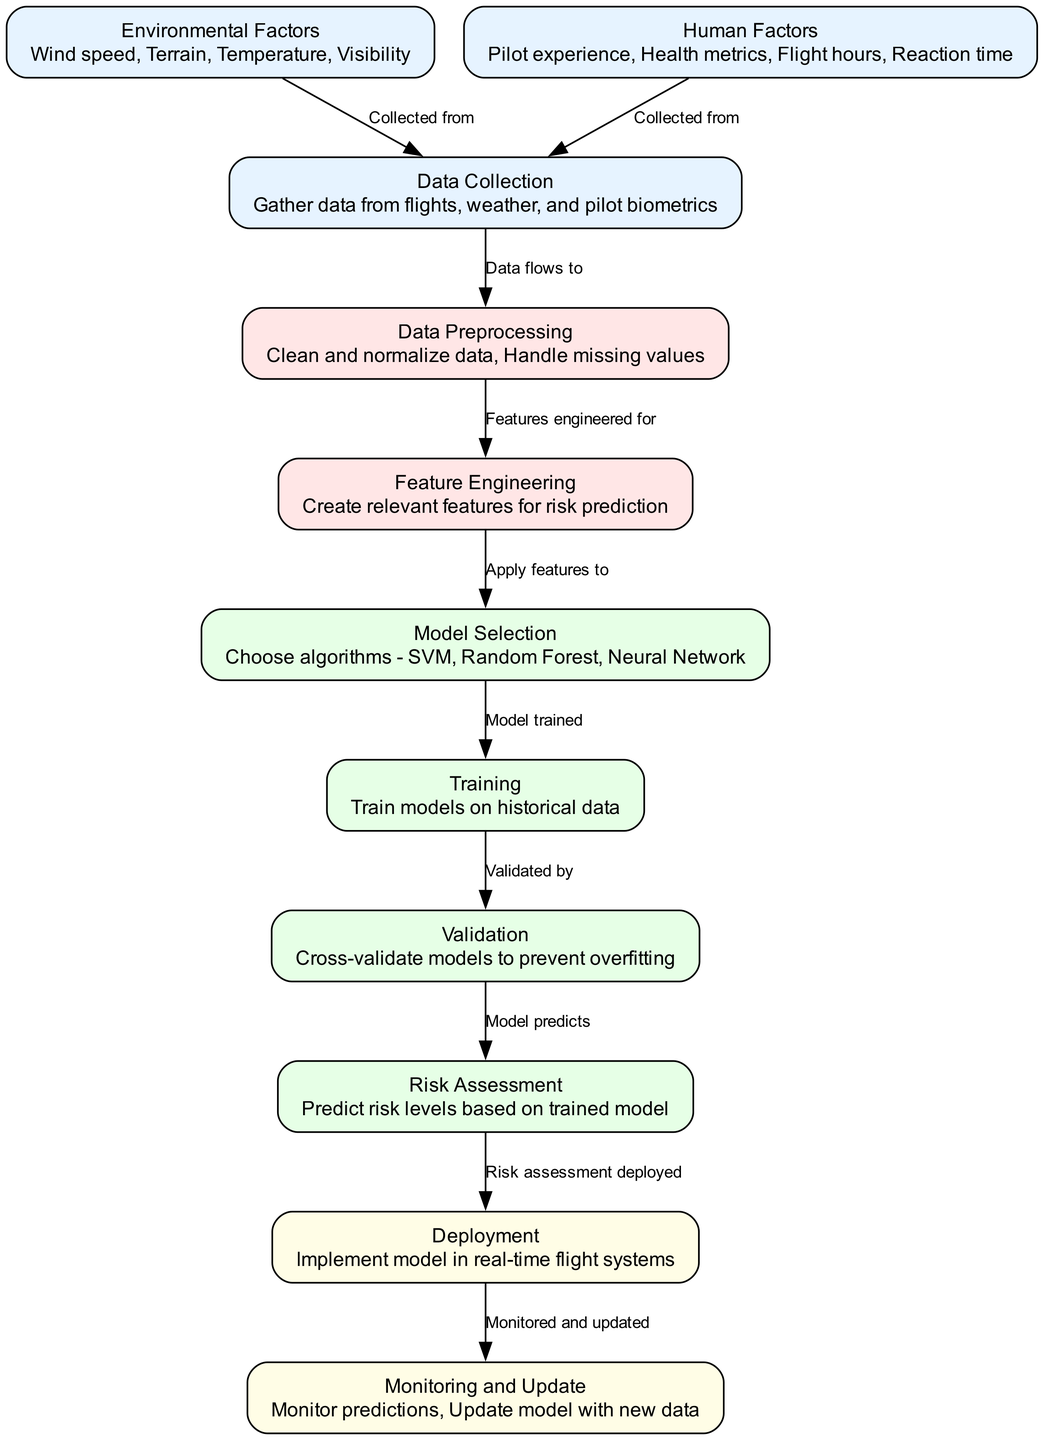What is the first step in the process? The diagram starts with the "Data Collection" node, which is the initial step where data is gathered from flights, weather, and pilot biometrics.
Answer: Data Collection How many types of factors are considered in the assessment? The diagram shows two distinct types of factors: "Environmental Factors" and "Human Factors," detailing both in separate nodes.
Answer: Two Which node provides features for model selection? The "Feature Engineering" node processes data collected in the "Data Preprocessing" stage and creates relevant features that are applied in "Model Selection."
Answer: Feature Engineering What type of algorithm can be selected in the "Model Selection" node? The "Model Selection" node allows for various algorithm choices, including SVM, Random Forest, and Neural Network.
Answer: SVM, Random Forest, Neural Network What is the final step after monitoring and updating the model? The "Monitoring and Update" node is the last step in the diagram, indicating that the model is continually watched and updated with new data.
Answer: Monitoring and Update How does data flow from environmental factors to the assessment process? The "Environmental Factors" node directs its data to the "Data Collection" node, which gathers all relevant data and prepares it for the subsequent steps leading to the "Risk Assessment."
Answer: Data Collection What is trained on historical data? The "Training" node is responsible for training the models using the data that was processed earlier in the pipeline, specifically historical data related to the previously gathered information.
Answer: Training Which stage involves cross-validation? The "Validation" stage is crucial for evaluating the models and involves cross-validation to ensure that the models do not overfit to the training data.
Answer: Validation What happens after the risk assessment is predicted? After the "Risk Assessment," the resultant evaluations are deployed in the "Deployment" step, signifying that the predictions are implemented in real-time flight systems.
Answer: Deployment 